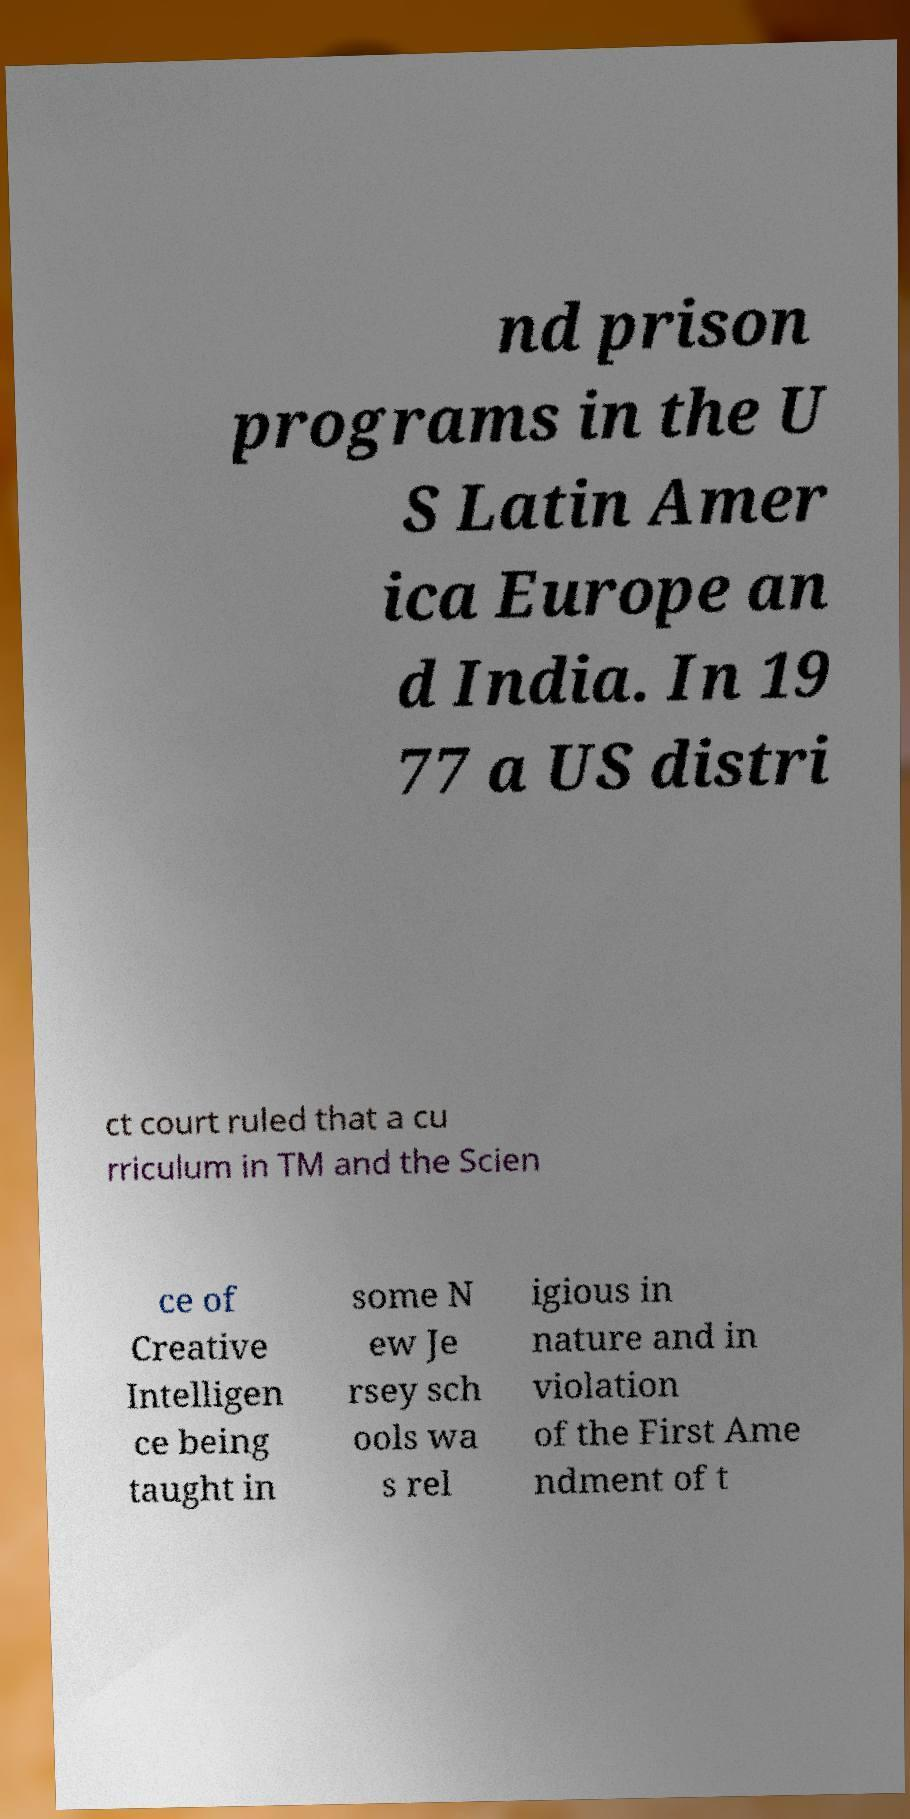Can you accurately transcribe the text from the provided image for me? nd prison programs in the U S Latin Amer ica Europe an d India. In 19 77 a US distri ct court ruled that a cu rriculum in TM and the Scien ce of Creative Intelligen ce being taught in some N ew Je rsey sch ools wa s rel igious in nature and in violation of the First Ame ndment of t 